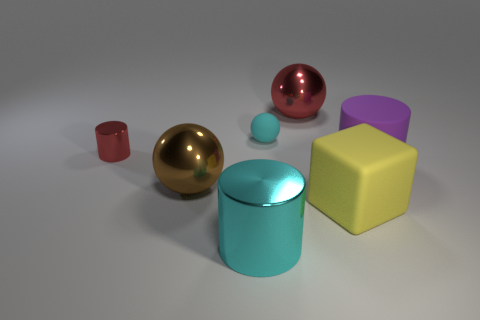Do the small matte thing and the large metal cylinder have the same color?
Provide a short and direct response. Yes. What material is the object that is the same color as the big metallic cylinder?
Keep it short and to the point. Rubber. The other large sphere that is made of the same material as the brown ball is what color?
Provide a succinct answer. Red. There is a red metal thing that is the same size as the yellow object; what shape is it?
Keep it short and to the point. Sphere. Do the small sphere and the large ball behind the large rubber cylinder have the same color?
Offer a very short reply. No. How many other small balls have the same color as the tiny matte ball?
Give a very brief answer. 0. How big is the cyan object in front of the small cyan rubber ball to the right of the big brown metallic thing?
Your answer should be compact. Large. How many objects are either objects left of the yellow matte thing or large purple matte things?
Ensure brevity in your answer.  6. Are there any green cylinders that have the same size as the purple rubber cylinder?
Give a very brief answer. No. Is there a large brown sphere behind the thing on the right side of the large yellow block?
Ensure brevity in your answer.  No. 